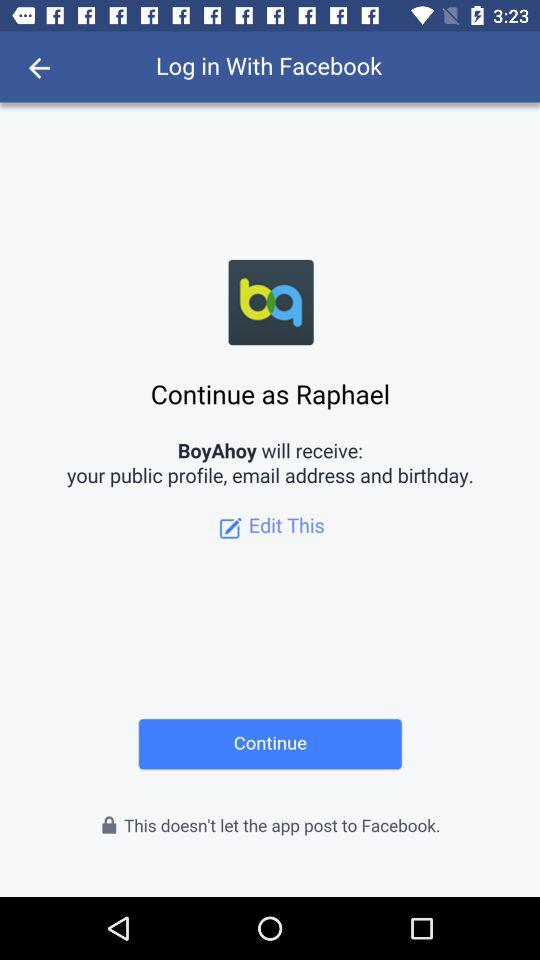What is the user name? The user name is Raphael. 